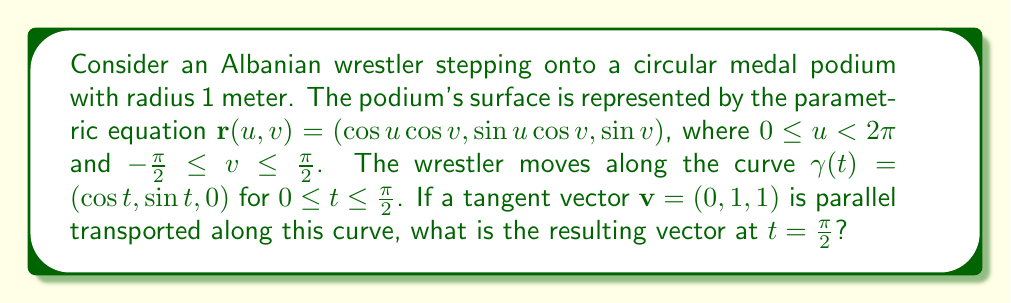Solve this math problem. To solve this problem, we'll follow these steps:

1) First, we need to calculate the metric tensor $g_{ij}$ of the surface:
   $$\mathbf{r}_u = (-\sin u \cos v, \cos u \cos v, 0)$$
   $$\mathbf{r}_v = (-\cos u \sin v, -\sin u \sin v, \cos v)$$
   
   $$g_{11} = \cos^2 v, \quad g_{12} = g_{21} = 0, \quad g_{22} = 1$$

2) Next, we calculate the Christoffel symbols:
   $$\Gamma_{11}^1 = 0, \quad \Gamma_{11}^2 = \sin v \cos v, \quad \Gamma_{12}^1 = \Gamma_{21}^1 = \tan v$$
   $$\Gamma_{12}^2 = \Gamma_{21}^2 = \Gamma_{22}^1 = \Gamma_{22}^2 = 0$$

3) The parallel transport equation is:
   $$\frac{dv^i}{dt} + \Gamma_{jk}^i \frac{dx^j}{dt} v^k = 0$$

4) For our curve $\gamma(t) = (\cos t, \sin t, 0)$, we have:
   $$\frac{dx^1}{dt} = -\sin t, \quad \frac{dx^2}{dt} = \cos t, \quad \frac{dx^3}{dt} = 0$$

5) Substituting into the parallel transport equation:
   $$\frac{dv^1}{dt} + \Gamma_{11}^1 (-\sin t) v^1 + \Gamma_{21}^1 (\cos t) v^1 = 0$$
   $$\frac{dv^2}{dt} + \Gamma_{11}^2 (-\sin t) v^1 + \Gamma_{21}^2 (\cos t) v^1 = 0$$

6) Simplifying:
   $$\frac{dv^1}{dt} = 0$$
   $$\frac{dv^2}{dt} = 0$$

7) Integrating from $t = 0$ to $t = \frac{\pi}{2}$:
   $$v^1(\frac{\pi}{2}) = v^1(0) = 0$$
   $$v^2(\frac{\pi}{2}) = v^2(0) = 1$$

8) The third component $v^3$ remains constant as it's perpendicular to the surface.

Therefore, the parallel transported vector at $t = \frac{\pi}{2}$ is $(0, 1, 1)$.
Answer: $(0, 1, 1)$ 